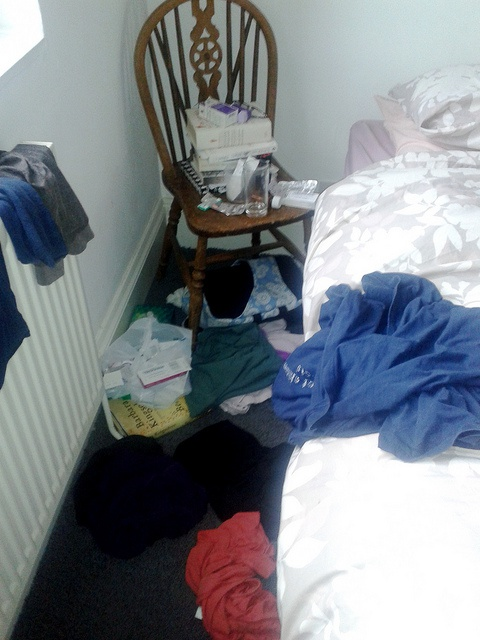Describe the objects in this image and their specific colors. I can see bed in white, blue, gray, and navy tones and chair in white, black, gray, and maroon tones in this image. 